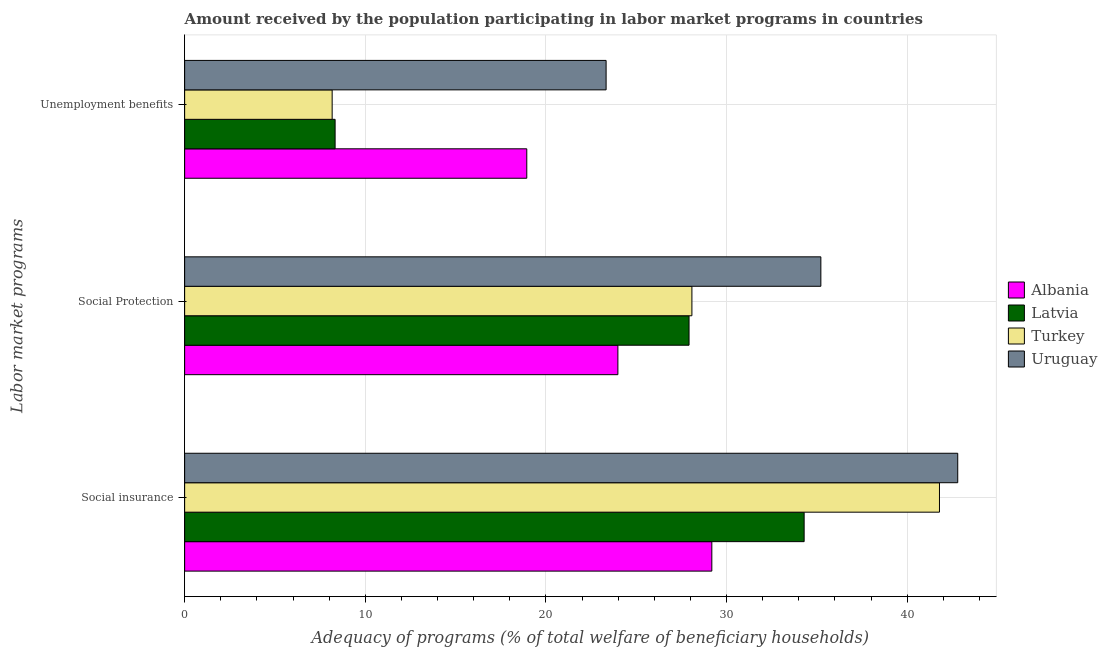How many groups of bars are there?
Offer a terse response. 3. Are the number of bars per tick equal to the number of legend labels?
Your response must be concise. Yes. Are the number of bars on each tick of the Y-axis equal?
Your response must be concise. Yes. What is the label of the 2nd group of bars from the top?
Offer a very short reply. Social Protection. What is the amount received by the population participating in social insurance programs in Albania?
Your answer should be very brief. 29.19. Across all countries, what is the maximum amount received by the population participating in social insurance programs?
Provide a short and direct response. 42.8. Across all countries, what is the minimum amount received by the population participating in unemployment benefits programs?
Provide a short and direct response. 8.17. In which country was the amount received by the population participating in social insurance programs maximum?
Your answer should be compact. Uruguay. In which country was the amount received by the population participating in social insurance programs minimum?
Provide a short and direct response. Albania. What is the total amount received by the population participating in social insurance programs in the graph?
Your answer should be compact. 148.07. What is the difference between the amount received by the population participating in social protection programs in Turkey and that in Latvia?
Provide a short and direct response. 0.16. What is the difference between the amount received by the population participating in social insurance programs in Turkey and the amount received by the population participating in unemployment benefits programs in Latvia?
Offer a terse response. 33.46. What is the average amount received by the population participating in social insurance programs per country?
Give a very brief answer. 37.02. What is the difference between the amount received by the population participating in social insurance programs and amount received by the population participating in unemployment benefits programs in Uruguay?
Provide a succinct answer. 19.47. In how many countries, is the amount received by the population participating in social protection programs greater than 34 %?
Your response must be concise. 1. What is the ratio of the amount received by the population participating in social protection programs in Turkey to that in Latvia?
Your answer should be very brief. 1.01. What is the difference between the highest and the second highest amount received by the population participating in social insurance programs?
Give a very brief answer. 1.01. What is the difference between the highest and the lowest amount received by the population participating in social insurance programs?
Provide a short and direct response. 13.61. Is the sum of the amount received by the population participating in social insurance programs in Latvia and Uruguay greater than the maximum amount received by the population participating in unemployment benefits programs across all countries?
Your response must be concise. Yes. What does the 3rd bar from the top in Social Protection represents?
Keep it short and to the point. Latvia. What does the 3rd bar from the bottom in Social Protection represents?
Your answer should be compact. Turkey. Is it the case that in every country, the sum of the amount received by the population participating in social insurance programs and amount received by the population participating in social protection programs is greater than the amount received by the population participating in unemployment benefits programs?
Make the answer very short. Yes. What is the difference between two consecutive major ticks on the X-axis?
Offer a very short reply. 10. Are the values on the major ticks of X-axis written in scientific E-notation?
Ensure brevity in your answer.  No. Does the graph contain any zero values?
Give a very brief answer. No. Does the graph contain grids?
Offer a terse response. Yes. How many legend labels are there?
Give a very brief answer. 4. What is the title of the graph?
Offer a terse response. Amount received by the population participating in labor market programs in countries. What is the label or title of the X-axis?
Provide a succinct answer. Adequacy of programs (% of total welfare of beneficiary households). What is the label or title of the Y-axis?
Provide a short and direct response. Labor market programs. What is the Adequacy of programs (% of total welfare of beneficiary households) in Albania in Social insurance?
Make the answer very short. 29.19. What is the Adequacy of programs (% of total welfare of beneficiary households) of Latvia in Social insurance?
Provide a succinct answer. 34.3. What is the Adequacy of programs (% of total welfare of beneficiary households) of Turkey in Social insurance?
Provide a succinct answer. 41.79. What is the Adequacy of programs (% of total welfare of beneficiary households) of Uruguay in Social insurance?
Your response must be concise. 42.8. What is the Adequacy of programs (% of total welfare of beneficiary households) in Albania in Social Protection?
Provide a short and direct response. 23.99. What is the Adequacy of programs (% of total welfare of beneficiary households) of Latvia in Social Protection?
Your answer should be very brief. 27.93. What is the Adequacy of programs (% of total welfare of beneficiary households) in Turkey in Social Protection?
Offer a terse response. 28.08. What is the Adequacy of programs (% of total welfare of beneficiary households) in Uruguay in Social Protection?
Offer a very short reply. 35.22. What is the Adequacy of programs (% of total welfare of beneficiary households) in Albania in Unemployment benefits?
Give a very brief answer. 18.94. What is the Adequacy of programs (% of total welfare of beneficiary households) of Latvia in Unemployment benefits?
Your answer should be compact. 8.33. What is the Adequacy of programs (% of total welfare of beneficiary households) of Turkey in Unemployment benefits?
Give a very brief answer. 8.17. What is the Adequacy of programs (% of total welfare of beneficiary households) in Uruguay in Unemployment benefits?
Offer a very short reply. 23.33. Across all Labor market programs, what is the maximum Adequacy of programs (% of total welfare of beneficiary households) in Albania?
Keep it short and to the point. 29.19. Across all Labor market programs, what is the maximum Adequacy of programs (% of total welfare of beneficiary households) of Latvia?
Your answer should be compact. 34.3. Across all Labor market programs, what is the maximum Adequacy of programs (% of total welfare of beneficiary households) of Turkey?
Offer a terse response. 41.79. Across all Labor market programs, what is the maximum Adequacy of programs (% of total welfare of beneficiary households) in Uruguay?
Your response must be concise. 42.8. Across all Labor market programs, what is the minimum Adequacy of programs (% of total welfare of beneficiary households) in Albania?
Offer a terse response. 18.94. Across all Labor market programs, what is the minimum Adequacy of programs (% of total welfare of beneficiary households) of Latvia?
Your response must be concise. 8.33. Across all Labor market programs, what is the minimum Adequacy of programs (% of total welfare of beneficiary households) in Turkey?
Provide a short and direct response. 8.17. Across all Labor market programs, what is the minimum Adequacy of programs (% of total welfare of beneficiary households) in Uruguay?
Your answer should be very brief. 23.33. What is the total Adequacy of programs (% of total welfare of beneficiary households) in Albania in the graph?
Provide a succinct answer. 72.11. What is the total Adequacy of programs (% of total welfare of beneficiary households) in Latvia in the graph?
Keep it short and to the point. 70.55. What is the total Adequacy of programs (% of total welfare of beneficiary households) in Turkey in the graph?
Ensure brevity in your answer.  78.04. What is the total Adequacy of programs (% of total welfare of beneficiary households) of Uruguay in the graph?
Your response must be concise. 101.35. What is the difference between the Adequacy of programs (% of total welfare of beneficiary households) of Albania in Social insurance and that in Social Protection?
Your response must be concise. 5.2. What is the difference between the Adequacy of programs (% of total welfare of beneficiary households) in Latvia in Social insurance and that in Social Protection?
Your answer should be compact. 6.37. What is the difference between the Adequacy of programs (% of total welfare of beneficiary households) of Turkey in Social insurance and that in Social Protection?
Your answer should be very brief. 13.71. What is the difference between the Adequacy of programs (% of total welfare of beneficiary households) in Uruguay in Social insurance and that in Social Protection?
Offer a terse response. 7.58. What is the difference between the Adequacy of programs (% of total welfare of beneficiary households) in Albania in Social insurance and that in Unemployment benefits?
Offer a terse response. 10.24. What is the difference between the Adequacy of programs (% of total welfare of beneficiary households) in Latvia in Social insurance and that in Unemployment benefits?
Your answer should be very brief. 25.97. What is the difference between the Adequacy of programs (% of total welfare of beneficiary households) of Turkey in Social insurance and that in Unemployment benefits?
Keep it short and to the point. 33.62. What is the difference between the Adequacy of programs (% of total welfare of beneficiary households) in Uruguay in Social insurance and that in Unemployment benefits?
Your response must be concise. 19.47. What is the difference between the Adequacy of programs (% of total welfare of beneficiary households) of Albania in Social Protection and that in Unemployment benefits?
Your response must be concise. 5.04. What is the difference between the Adequacy of programs (% of total welfare of beneficiary households) in Latvia in Social Protection and that in Unemployment benefits?
Offer a terse response. 19.59. What is the difference between the Adequacy of programs (% of total welfare of beneficiary households) in Turkey in Social Protection and that in Unemployment benefits?
Provide a short and direct response. 19.92. What is the difference between the Adequacy of programs (% of total welfare of beneficiary households) of Uruguay in Social Protection and that in Unemployment benefits?
Offer a terse response. 11.89. What is the difference between the Adequacy of programs (% of total welfare of beneficiary households) of Albania in Social insurance and the Adequacy of programs (% of total welfare of beneficiary households) of Latvia in Social Protection?
Your response must be concise. 1.26. What is the difference between the Adequacy of programs (% of total welfare of beneficiary households) in Albania in Social insurance and the Adequacy of programs (% of total welfare of beneficiary households) in Turkey in Social Protection?
Provide a short and direct response. 1.1. What is the difference between the Adequacy of programs (% of total welfare of beneficiary households) of Albania in Social insurance and the Adequacy of programs (% of total welfare of beneficiary households) of Uruguay in Social Protection?
Provide a short and direct response. -6.04. What is the difference between the Adequacy of programs (% of total welfare of beneficiary households) of Latvia in Social insurance and the Adequacy of programs (% of total welfare of beneficiary households) of Turkey in Social Protection?
Offer a very short reply. 6.21. What is the difference between the Adequacy of programs (% of total welfare of beneficiary households) in Latvia in Social insurance and the Adequacy of programs (% of total welfare of beneficiary households) in Uruguay in Social Protection?
Give a very brief answer. -0.93. What is the difference between the Adequacy of programs (% of total welfare of beneficiary households) in Turkey in Social insurance and the Adequacy of programs (% of total welfare of beneficiary households) in Uruguay in Social Protection?
Keep it short and to the point. 6.57. What is the difference between the Adequacy of programs (% of total welfare of beneficiary households) of Albania in Social insurance and the Adequacy of programs (% of total welfare of beneficiary households) of Latvia in Unemployment benefits?
Ensure brevity in your answer.  20.86. What is the difference between the Adequacy of programs (% of total welfare of beneficiary households) of Albania in Social insurance and the Adequacy of programs (% of total welfare of beneficiary households) of Turkey in Unemployment benefits?
Your response must be concise. 21.02. What is the difference between the Adequacy of programs (% of total welfare of beneficiary households) of Albania in Social insurance and the Adequacy of programs (% of total welfare of beneficiary households) of Uruguay in Unemployment benefits?
Keep it short and to the point. 5.85. What is the difference between the Adequacy of programs (% of total welfare of beneficiary households) of Latvia in Social insurance and the Adequacy of programs (% of total welfare of beneficiary households) of Turkey in Unemployment benefits?
Offer a very short reply. 26.13. What is the difference between the Adequacy of programs (% of total welfare of beneficiary households) in Latvia in Social insurance and the Adequacy of programs (% of total welfare of beneficiary households) in Uruguay in Unemployment benefits?
Offer a terse response. 10.96. What is the difference between the Adequacy of programs (% of total welfare of beneficiary households) in Turkey in Social insurance and the Adequacy of programs (% of total welfare of beneficiary households) in Uruguay in Unemployment benefits?
Offer a very short reply. 18.46. What is the difference between the Adequacy of programs (% of total welfare of beneficiary households) in Albania in Social Protection and the Adequacy of programs (% of total welfare of beneficiary households) in Latvia in Unemployment benefits?
Provide a short and direct response. 15.65. What is the difference between the Adequacy of programs (% of total welfare of beneficiary households) in Albania in Social Protection and the Adequacy of programs (% of total welfare of beneficiary households) in Turkey in Unemployment benefits?
Offer a very short reply. 15.82. What is the difference between the Adequacy of programs (% of total welfare of beneficiary households) in Albania in Social Protection and the Adequacy of programs (% of total welfare of beneficiary households) in Uruguay in Unemployment benefits?
Keep it short and to the point. 0.65. What is the difference between the Adequacy of programs (% of total welfare of beneficiary households) of Latvia in Social Protection and the Adequacy of programs (% of total welfare of beneficiary households) of Turkey in Unemployment benefits?
Provide a succinct answer. 19.76. What is the difference between the Adequacy of programs (% of total welfare of beneficiary households) in Latvia in Social Protection and the Adequacy of programs (% of total welfare of beneficiary households) in Uruguay in Unemployment benefits?
Your response must be concise. 4.59. What is the difference between the Adequacy of programs (% of total welfare of beneficiary households) of Turkey in Social Protection and the Adequacy of programs (% of total welfare of beneficiary households) of Uruguay in Unemployment benefits?
Your response must be concise. 4.75. What is the average Adequacy of programs (% of total welfare of beneficiary households) of Albania per Labor market programs?
Provide a short and direct response. 24.04. What is the average Adequacy of programs (% of total welfare of beneficiary households) in Latvia per Labor market programs?
Give a very brief answer. 23.52. What is the average Adequacy of programs (% of total welfare of beneficiary households) in Turkey per Labor market programs?
Keep it short and to the point. 26.01. What is the average Adequacy of programs (% of total welfare of beneficiary households) in Uruguay per Labor market programs?
Offer a very short reply. 33.78. What is the difference between the Adequacy of programs (% of total welfare of beneficiary households) in Albania and Adequacy of programs (% of total welfare of beneficiary households) in Latvia in Social insurance?
Provide a succinct answer. -5.11. What is the difference between the Adequacy of programs (% of total welfare of beneficiary households) of Albania and Adequacy of programs (% of total welfare of beneficiary households) of Turkey in Social insurance?
Give a very brief answer. -12.6. What is the difference between the Adequacy of programs (% of total welfare of beneficiary households) of Albania and Adequacy of programs (% of total welfare of beneficiary households) of Uruguay in Social insurance?
Keep it short and to the point. -13.61. What is the difference between the Adequacy of programs (% of total welfare of beneficiary households) in Latvia and Adequacy of programs (% of total welfare of beneficiary households) in Turkey in Social insurance?
Your answer should be compact. -7.49. What is the difference between the Adequacy of programs (% of total welfare of beneficiary households) in Latvia and Adequacy of programs (% of total welfare of beneficiary households) in Uruguay in Social insurance?
Your answer should be compact. -8.5. What is the difference between the Adequacy of programs (% of total welfare of beneficiary households) of Turkey and Adequacy of programs (% of total welfare of beneficiary households) of Uruguay in Social insurance?
Your answer should be compact. -1.01. What is the difference between the Adequacy of programs (% of total welfare of beneficiary households) of Albania and Adequacy of programs (% of total welfare of beneficiary households) of Latvia in Social Protection?
Provide a short and direct response. -3.94. What is the difference between the Adequacy of programs (% of total welfare of beneficiary households) in Albania and Adequacy of programs (% of total welfare of beneficiary households) in Turkey in Social Protection?
Provide a succinct answer. -4.1. What is the difference between the Adequacy of programs (% of total welfare of beneficiary households) of Albania and Adequacy of programs (% of total welfare of beneficiary households) of Uruguay in Social Protection?
Your answer should be very brief. -11.24. What is the difference between the Adequacy of programs (% of total welfare of beneficiary households) of Latvia and Adequacy of programs (% of total welfare of beneficiary households) of Turkey in Social Protection?
Offer a terse response. -0.16. What is the difference between the Adequacy of programs (% of total welfare of beneficiary households) in Latvia and Adequacy of programs (% of total welfare of beneficiary households) in Uruguay in Social Protection?
Keep it short and to the point. -7.3. What is the difference between the Adequacy of programs (% of total welfare of beneficiary households) in Turkey and Adequacy of programs (% of total welfare of beneficiary households) in Uruguay in Social Protection?
Make the answer very short. -7.14. What is the difference between the Adequacy of programs (% of total welfare of beneficiary households) of Albania and Adequacy of programs (% of total welfare of beneficiary households) of Latvia in Unemployment benefits?
Your response must be concise. 10.61. What is the difference between the Adequacy of programs (% of total welfare of beneficiary households) in Albania and Adequacy of programs (% of total welfare of beneficiary households) in Turkey in Unemployment benefits?
Ensure brevity in your answer.  10.77. What is the difference between the Adequacy of programs (% of total welfare of beneficiary households) in Albania and Adequacy of programs (% of total welfare of beneficiary households) in Uruguay in Unemployment benefits?
Make the answer very short. -4.39. What is the difference between the Adequacy of programs (% of total welfare of beneficiary households) in Latvia and Adequacy of programs (% of total welfare of beneficiary households) in Turkey in Unemployment benefits?
Offer a very short reply. 0.16. What is the difference between the Adequacy of programs (% of total welfare of beneficiary households) of Latvia and Adequacy of programs (% of total welfare of beneficiary households) of Uruguay in Unemployment benefits?
Give a very brief answer. -15. What is the difference between the Adequacy of programs (% of total welfare of beneficiary households) of Turkey and Adequacy of programs (% of total welfare of beneficiary households) of Uruguay in Unemployment benefits?
Offer a very short reply. -15.17. What is the ratio of the Adequacy of programs (% of total welfare of beneficiary households) in Albania in Social insurance to that in Social Protection?
Ensure brevity in your answer.  1.22. What is the ratio of the Adequacy of programs (% of total welfare of beneficiary households) of Latvia in Social insurance to that in Social Protection?
Provide a short and direct response. 1.23. What is the ratio of the Adequacy of programs (% of total welfare of beneficiary households) in Turkey in Social insurance to that in Social Protection?
Provide a succinct answer. 1.49. What is the ratio of the Adequacy of programs (% of total welfare of beneficiary households) of Uruguay in Social insurance to that in Social Protection?
Provide a short and direct response. 1.22. What is the ratio of the Adequacy of programs (% of total welfare of beneficiary households) of Albania in Social insurance to that in Unemployment benefits?
Your answer should be very brief. 1.54. What is the ratio of the Adequacy of programs (% of total welfare of beneficiary households) of Latvia in Social insurance to that in Unemployment benefits?
Your response must be concise. 4.12. What is the ratio of the Adequacy of programs (% of total welfare of beneficiary households) of Turkey in Social insurance to that in Unemployment benefits?
Keep it short and to the point. 5.12. What is the ratio of the Adequacy of programs (% of total welfare of beneficiary households) in Uruguay in Social insurance to that in Unemployment benefits?
Provide a short and direct response. 1.83. What is the ratio of the Adequacy of programs (% of total welfare of beneficiary households) of Albania in Social Protection to that in Unemployment benefits?
Provide a short and direct response. 1.27. What is the ratio of the Adequacy of programs (% of total welfare of beneficiary households) of Latvia in Social Protection to that in Unemployment benefits?
Your response must be concise. 3.35. What is the ratio of the Adequacy of programs (% of total welfare of beneficiary households) in Turkey in Social Protection to that in Unemployment benefits?
Make the answer very short. 3.44. What is the ratio of the Adequacy of programs (% of total welfare of beneficiary households) in Uruguay in Social Protection to that in Unemployment benefits?
Offer a very short reply. 1.51. What is the difference between the highest and the second highest Adequacy of programs (% of total welfare of beneficiary households) in Albania?
Give a very brief answer. 5.2. What is the difference between the highest and the second highest Adequacy of programs (% of total welfare of beneficiary households) in Latvia?
Provide a short and direct response. 6.37. What is the difference between the highest and the second highest Adequacy of programs (% of total welfare of beneficiary households) in Turkey?
Your response must be concise. 13.71. What is the difference between the highest and the second highest Adequacy of programs (% of total welfare of beneficiary households) of Uruguay?
Ensure brevity in your answer.  7.58. What is the difference between the highest and the lowest Adequacy of programs (% of total welfare of beneficiary households) of Albania?
Ensure brevity in your answer.  10.24. What is the difference between the highest and the lowest Adequacy of programs (% of total welfare of beneficiary households) in Latvia?
Your response must be concise. 25.97. What is the difference between the highest and the lowest Adequacy of programs (% of total welfare of beneficiary households) of Turkey?
Ensure brevity in your answer.  33.62. What is the difference between the highest and the lowest Adequacy of programs (% of total welfare of beneficiary households) in Uruguay?
Provide a short and direct response. 19.47. 